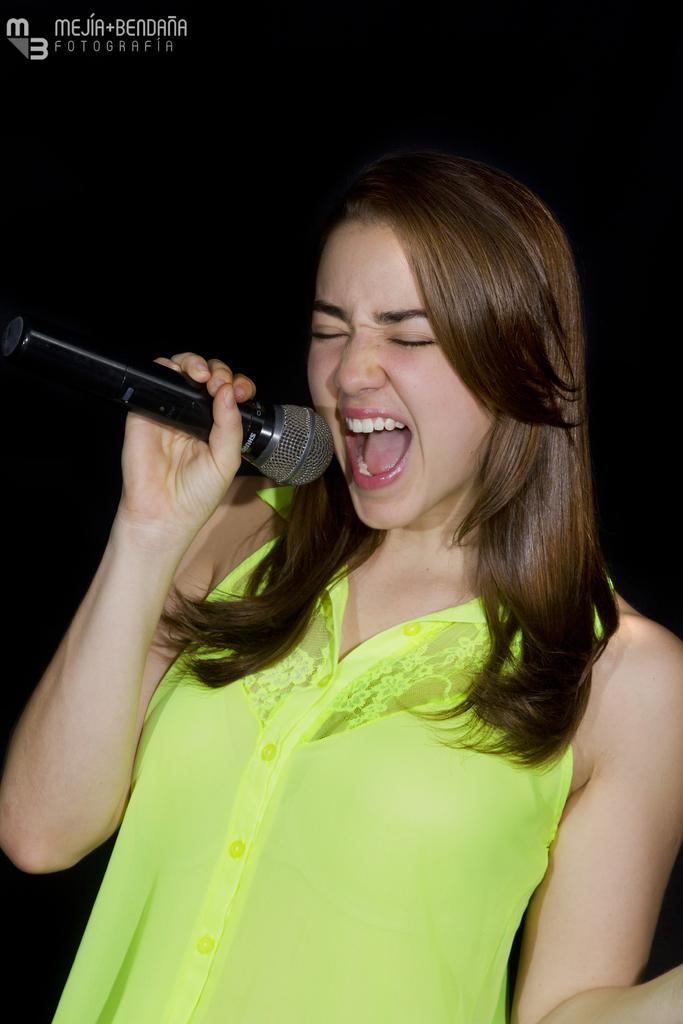Who is the main subject in the image? There is a woman in the image. What is the woman wearing? The woman is wearing a green dress. What is the woman holding in the image? The woman is holding a microphone. What can be seen in the background of the image? The background of the image appears to be black. What type of plant is growing out of the woman's stomach in the image? There is no plant growing out of the woman's stomach in the image; she is not depicted as having a plant or any other object protruding from her body. 